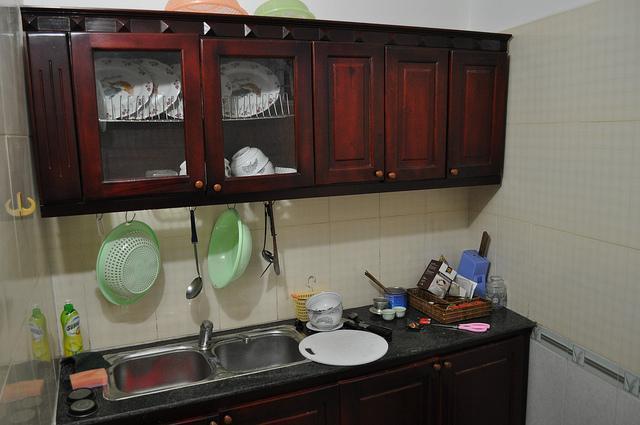What is the pink item on the counter?
From the following set of four choices, select the accurate answer to respond to the question.
Options: Scissor handle, spoon, napkin, fork. Scissor handle. What color are the noodle strainers hanging underneath of the cupboard and above the sink?
Select the accurate answer and provide justification: `Answer: choice
Rationale: srationale.`
Options: Two, three, five, four. Answer: two.
Rationale: There are two colors. 